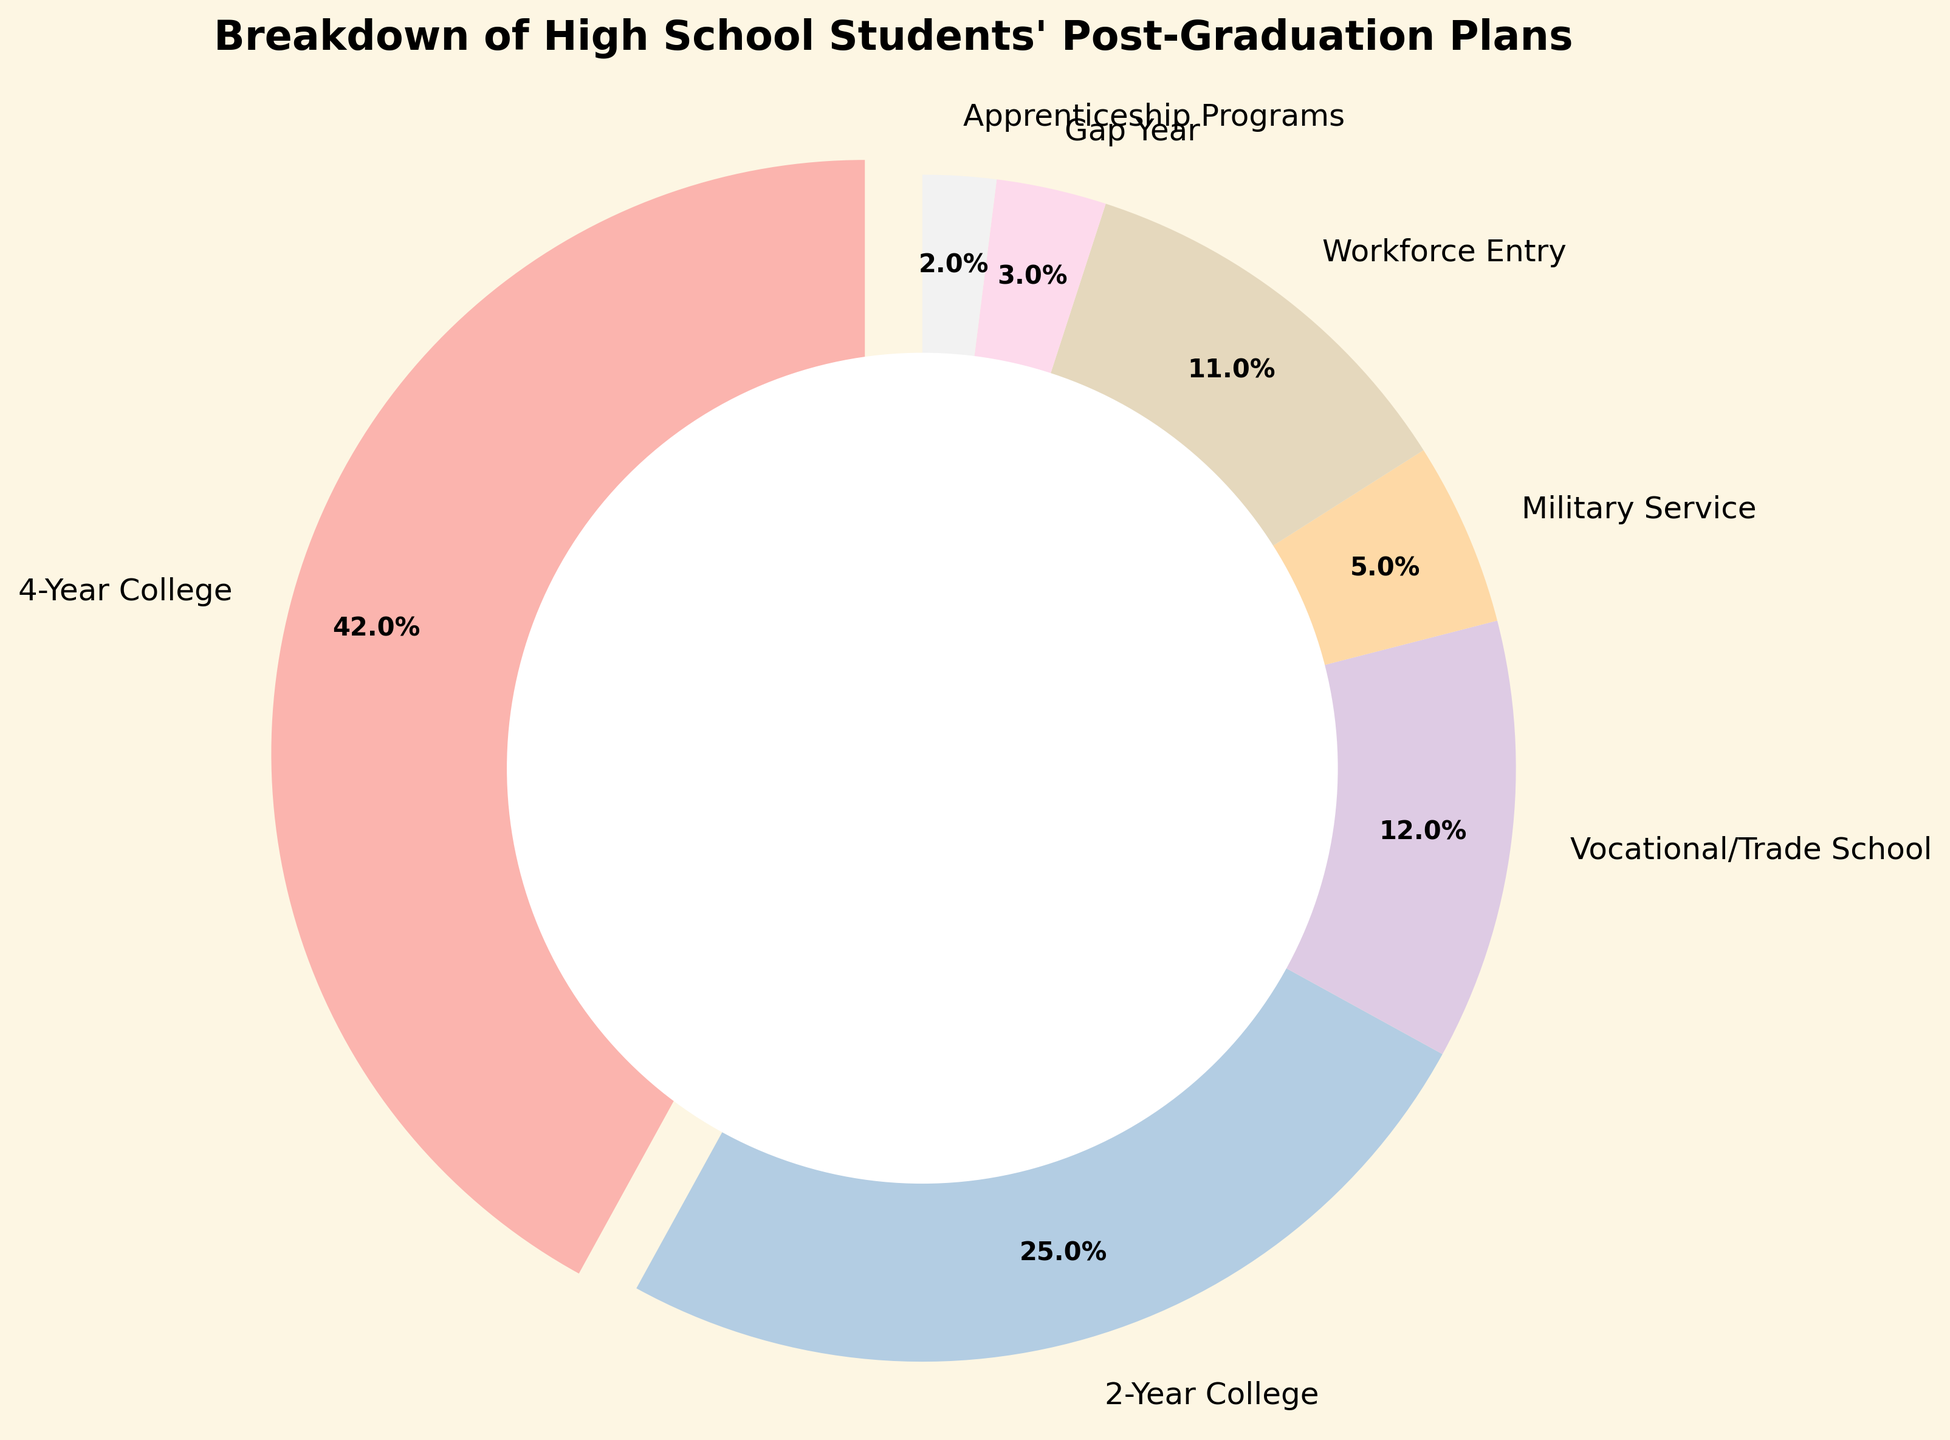Which category has the highest percentage of post-graduation plans? The highest percentage slice in the pie chart is the one representing 4-Year College, as it is exploded out from the pie and has a 42% label.
Answer: 4-Year College How much higher is the percentage of students planning to attend a 4-Year College compared to those entering the Workforce? The percentage for 4-Year College is 42%, and for Workforce Entry, it is 11%. The difference is calculated as 42% - 11%.
Answer: 31% What is the combined percentage of students planning to attend either a 2-Year College or a Vocational/Trade School? Add the percentages of 2-Year College (25%) and Vocational/Trade School (12%). The combined percentage is 25% + 12%.
Answer: 37% Which categories together make up less than 10% of the total plans? Categories with less than 10% are Gap Year (3%) and Apprenticeship Programs (2%).
Answer: Gap Year, Apprenticeship Programs Is the percentage of students planning to pursue Military Service greater than those planning to take a Gap Year? The pie chart shows 5% for Military Service and 3% for Gap Year. Since 5% is greater than 3%, the answer is yes.
Answer: Yes What is the percentage difference between 2-Year College and Vocational/Trade School? The percentage for 2-Year College is 25%, and for Vocational/Trade School, it is 12%. The percentage difference is 25% - 12%.
Answer: 13% How many percentage points more students are entering 4-Year Colleges compared to taking a Gap Year and entering Apprenticeship Programs combined? The percentage for a 4-Year College is 42%. The combined percentage for Gap Year and Apprenticeship Programs is 3% + 2% = 5%. The difference is 42% - 5%.
Answer: 37% Which sections of the pie chart have percentages that are multiples of 5? From the chart, sections with percentages of 5% and greater and multiples of 5 are 4-Year College (42% is not a multiple), 2-Year College (25%), Military Service (5%).
Answer: 2-Year College, Military Service What percentage of students are planning either Vocational/Trade School or Military Service? Add the percentages of Vocational/Trade School (12%) and Military Service (5%). The combined percentage is 12% + 5%.
Answer: 17% Compare the percentage of students entering the Workforce with those taking a Gap Year and attending Apprenticeship Programs combined. Which is higher? The percentage for Workforce Entry is 11%. The combined percentage for Gap Year and Apprenticeship Programs is 3% + 2% = 5%. Since 11% is higher than 5%, the Workforce Entry percentage is higher.
Answer: Workforce Entry 